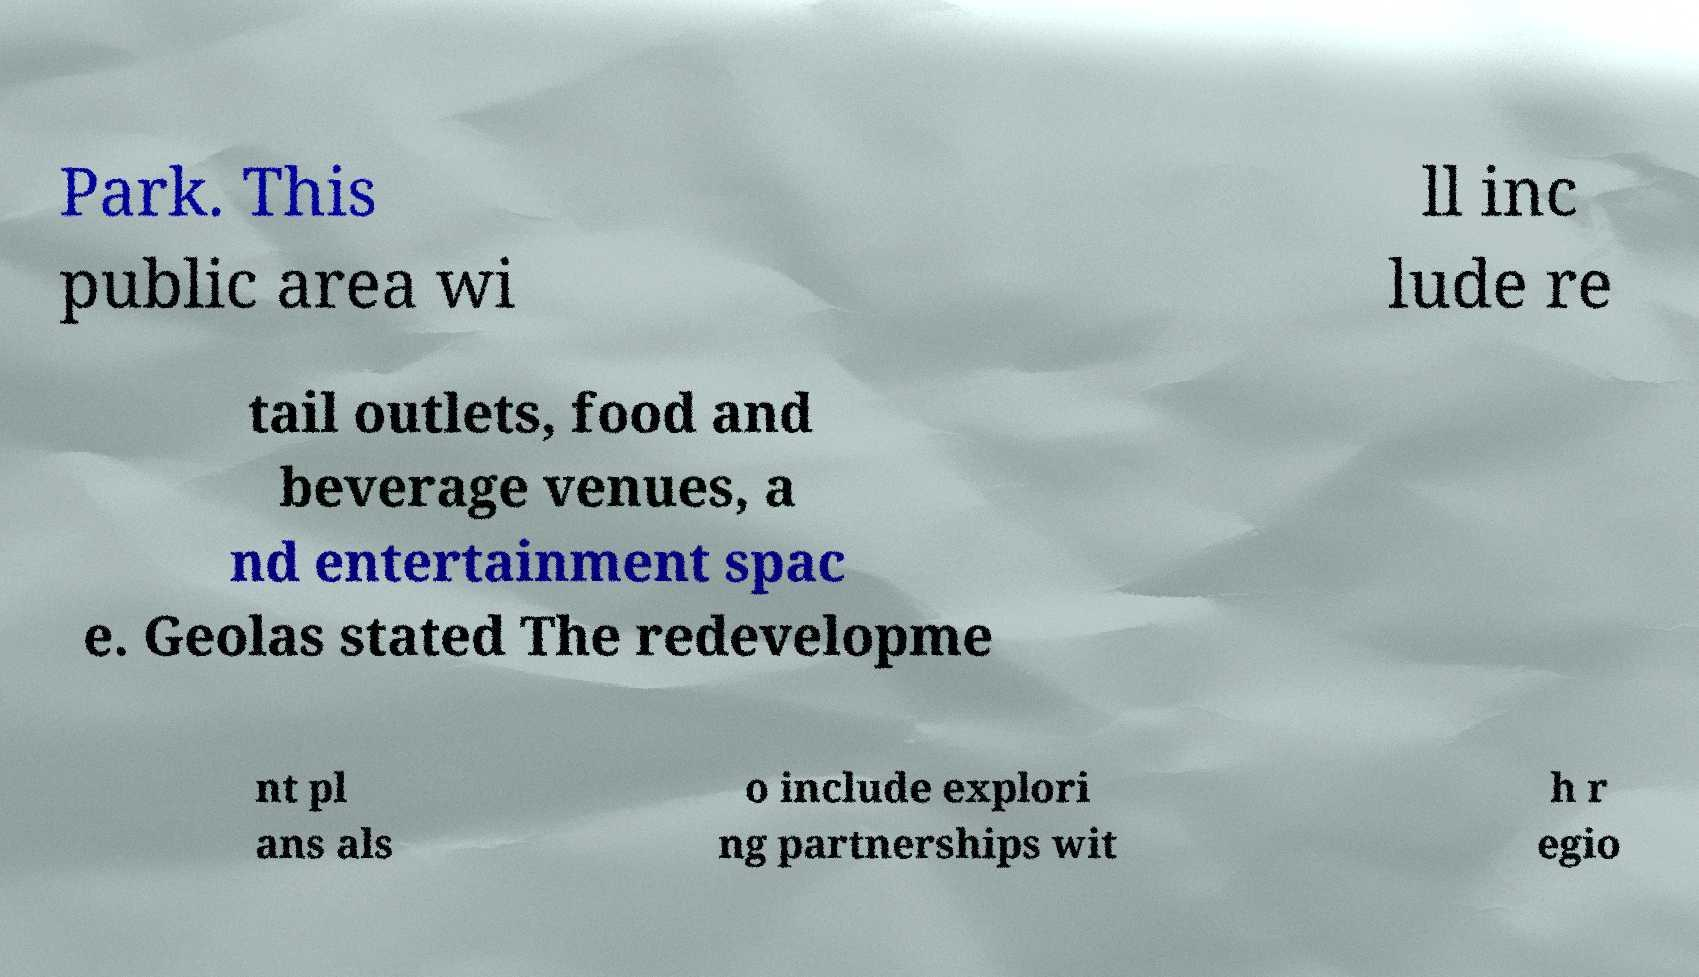There's text embedded in this image that I need extracted. Can you transcribe it verbatim? Park. This public area wi ll inc lude re tail outlets, food and beverage venues, a nd entertainment spac e. Geolas stated The redevelopme nt pl ans als o include explori ng partnerships wit h r egio 